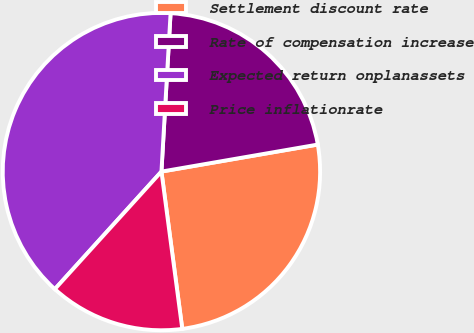Convert chart. <chart><loc_0><loc_0><loc_500><loc_500><pie_chart><fcel>Settlement discount rate<fcel>Rate of compensation increase<fcel>Expected return onplanassets<fcel>Price inflationrate<nl><fcel>25.63%<fcel>21.36%<fcel>39.2%<fcel>13.82%<nl></chart> 